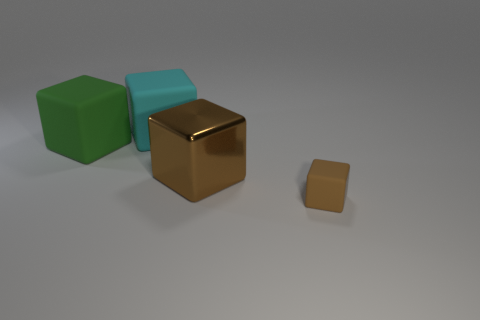Subtract all cyan blocks. How many blocks are left? 3 Add 3 big brown metallic cubes. How many objects exist? 7 Subtract all big brown blocks. How many blocks are left? 3 Subtract all cyan cylinders. How many green cubes are left? 1 Add 3 large cyan rubber blocks. How many large cyan rubber blocks are left? 4 Add 2 cyan objects. How many cyan objects exist? 3 Subtract 0 yellow balls. How many objects are left? 4 Subtract 3 cubes. How many cubes are left? 1 Subtract all purple blocks. Subtract all red cylinders. How many blocks are left? 4 Subtract all tiny brown rubber blocks. Subtract all big green blocks. How many objects are left? 2 